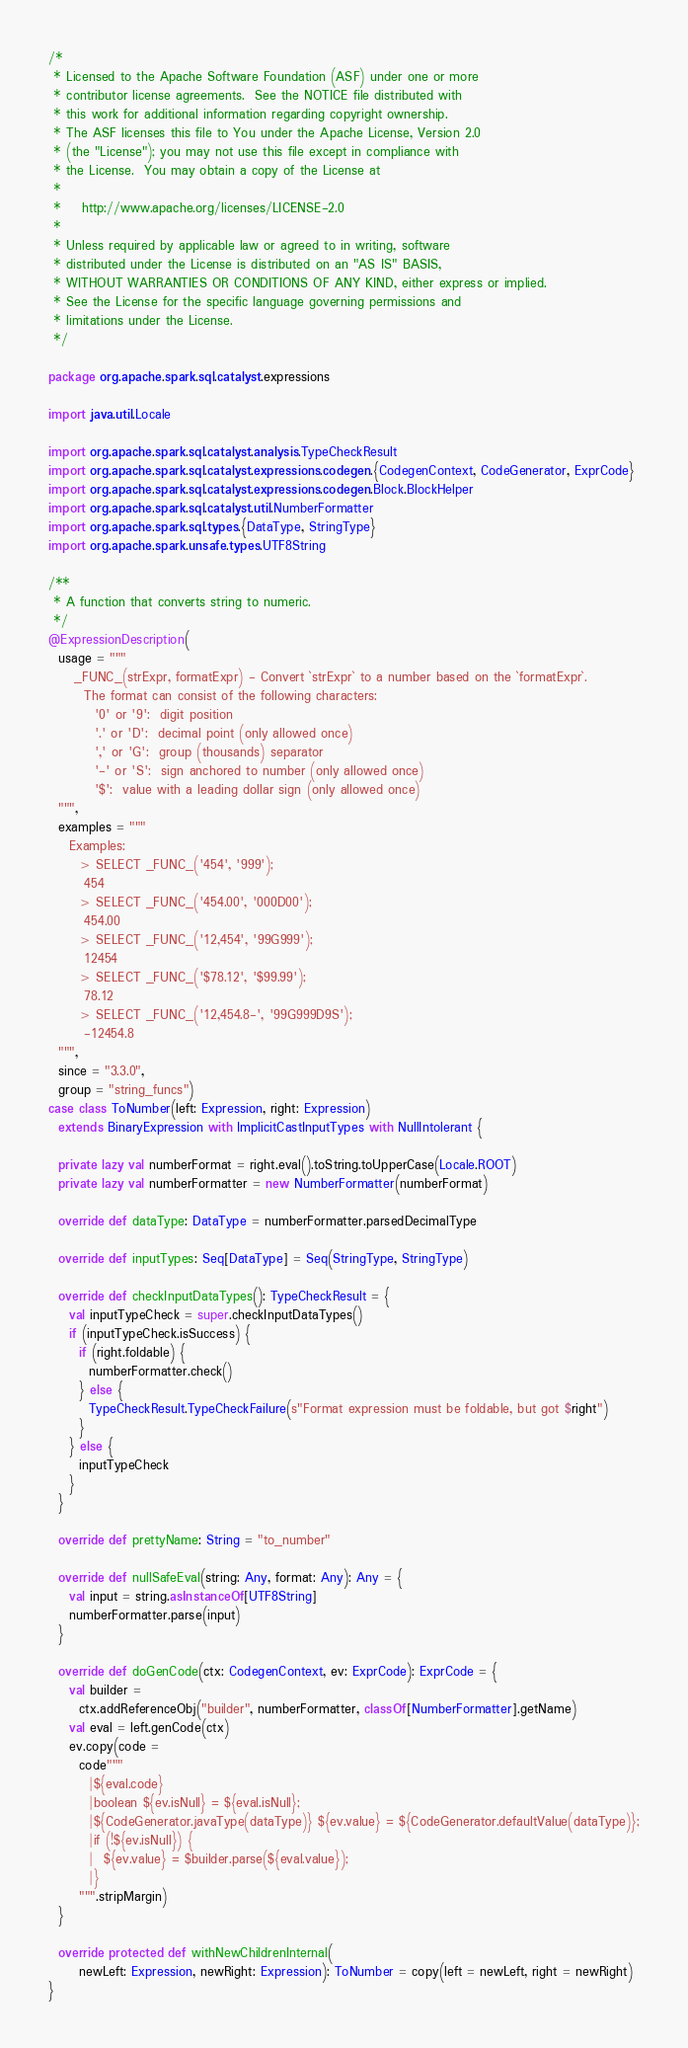<code> <loc_0><loc_0><loc_500><loc_500><_Scala_>/*
 * Licensed to the Apache Software Foundation (ASF) under one or more
 * contributor license agreements.  See the NOTICE file distributed with
 * this work for additional information regarding copyright ownership.
 * The ASF licenses this file to You under the Apache License, Version 2.0
 * (the "License"); you may not use this file except in compliance with
 * the License.  You may obtain a copy of the License at
 *
 *    http://www.apache.org/licenses/LICENSE-2.0
 *
 * Unless required by applicable law or agreed to in writing, software
 * distributed under the License is distributed on an "AS IS" BASIS,
 * WITHOUT WARRANTIES OR CONDITIONS OF ANY KIND, either express or implied.
 * See the License for the specific language governing permissions and
 * limitations under the License.
 */

package org.apache.spark.sql.catalyst.expressions

import java.util.Locale

import org.apache.spark.sql.catalyst.analysis.TypeCheckResult
import org.apache.spark.sql.catalyst.expressions.codegen.{CodegenContext, CodeGenerator, ExprCode}
import org.apache.spark.sql.catalyst.expressions.codegen.Block.BlockHelper
import org.apache.spark.sql.catalyst.util.NumberFormatter
import org.apache.spark.sql.types.{DataType, StringType}
import org.apache.spark.unsafe.types.UTF8String

/**
 * A function that converts string to numeric.
 */
@ExpressionDescription(
  usage = """
     _FUNC_(strExpr, formatExpr) - Convert `strExpr` to a number based on the `formatExpr`.
       The format can consist of the following characters:
         '0' or '9':  digit position
         '.' or 'D':  decimal point (only allowed once)
         ',' or 'G':  group (thousands) separator
         '-' or 'S':  sign anchored to number (only allowed once)
         '$':  value with a leading dollar sign (only allowed once)
  """,
  examples = """
    Examples:
      > SELECT _FUNC_('454', '999');
       454
      > SELECT _FUNC_('454.00', '000D00');
       454.00
      > SELECT _FUNC_('12,454', '99G999');
       12454
      > SELECT _FUNC_('$78.12', '$99.99');
       78.12
      > SELECT _FUNC_('12,454.8-', '99G999D9S');
       -12454.8
  """,
  since = "3.3.0",
  group = "string_funcs")
case class ToNumber(left: Expression, right: Expression)
  extends BinaryExpression with ImplicitCastInputTypes with NullIntolerant {

  private lazy val numberFormat = right.eval().toString.toUpperCase(Locale.ROOT)
  private lazy val numberFormatter = new NumberFormatter(numberFormat)

  override def dataType: DataType = numberFormatter.parsedDecimalType

  override def inputTypes: Seq[DataType] = Seq(StringType, StringType)

  override def checkInputDataTypes(): TypeCheckResult = {
    val inputTypeCheck = super.checkInputDataTypes()
    if (inputTypeCheck.isSuccess) {
      if (right.foldable) {
        numberFormatter.check()
      } else {
        TypeCheckResult.TypeCheckFailure(s"Format expression must be foldable, but got $right")
      }
    } else {
      inputTypeCheck
    }
  }

  override def prettyName: String = "to_number"

  override def nullSafeEval(string: Any, format: Any): Any = {
    val input = string.asInstanceOf[UTF8String]
    numberFormatter.parse(input)
  }

  override def doGenCode(ctx: CodegenContext, ev: ExprCode): ExprCode = {
    val builder =
      ctx.addReferenceObj("builder", numberFormatter, classOf[NumberFormatter].getName)
    val eval = left.genCode(ctx)
    ev.copy(code =
      code"""
        |${eval.code}
        |boolean ${ev.isNull} = ${eval.isNull};
        |${CodeGenerator.javaType(dataType)} ${ev.value} = ${CodeGenerator.defaultValue(dataType)};
        |if (!${ev.isNull}) {
        |  ${ev.value} = $builder.parse(${eval.value});
        |}
      """.stripMargin)
  }

  override protected def withNewChildrenInternal(
      newLeft: Expression, newRight: Expression): ToNumber = copy(left = newLeft, right = newRight)
}

</code> 